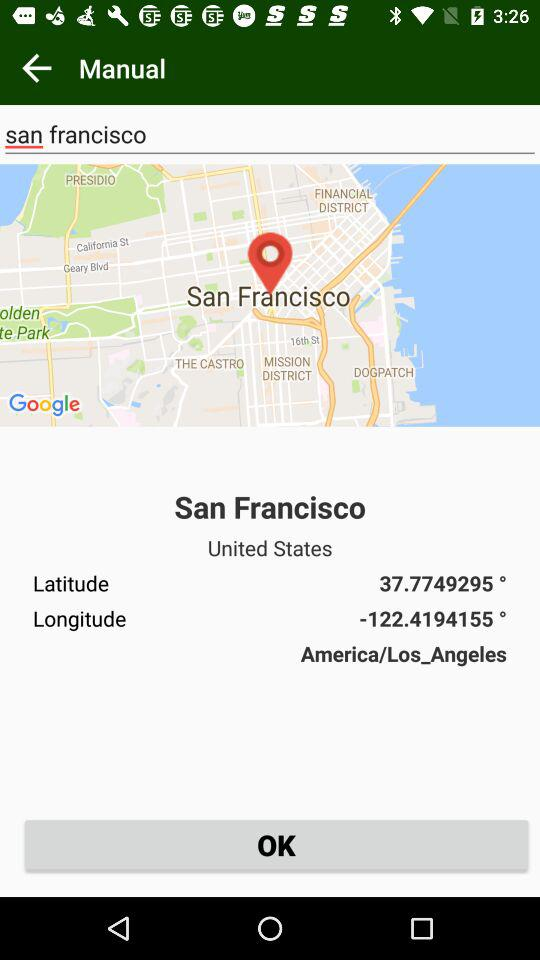What city was selected? The city was San Francisco. 